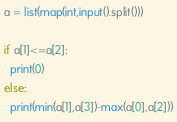<code> <loc_0><loc_0><loc_500><loc_500><_Python_>a = list(map(int,input().split()))

if a[1]<=a[2]:
  print(0)
else:
  print(min(a[1],a[3])-max(a[0],a[2]))</code> 